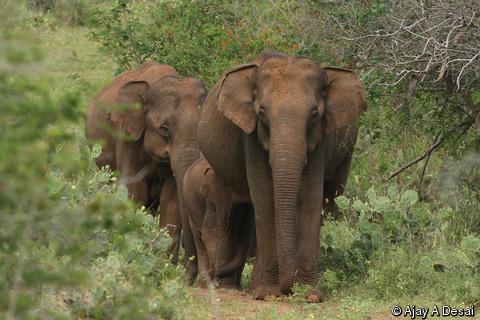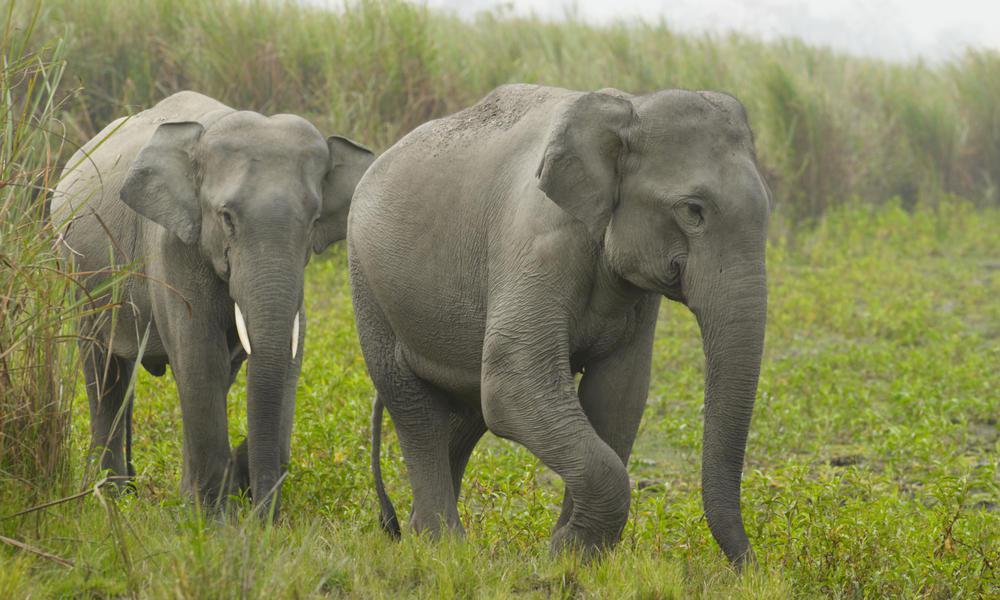The first image is the image on the left, the second image is the image on the right. Given the left and right images, does the statement "There are two adult elephants in the image on the right." hold true? Answer yes or no. Yes. The first image is the image on the left, the second image is the image on the right. For the images shown, is this caption "Three elephants walk together in the image on the left." true? Answer yes or no. Yes. The first image is the image on the left, the second image is the image on the right. Considering the images on both sides, is "One image includes leftward-facing adult and young elephants." valid? Answer yes or no. No. 